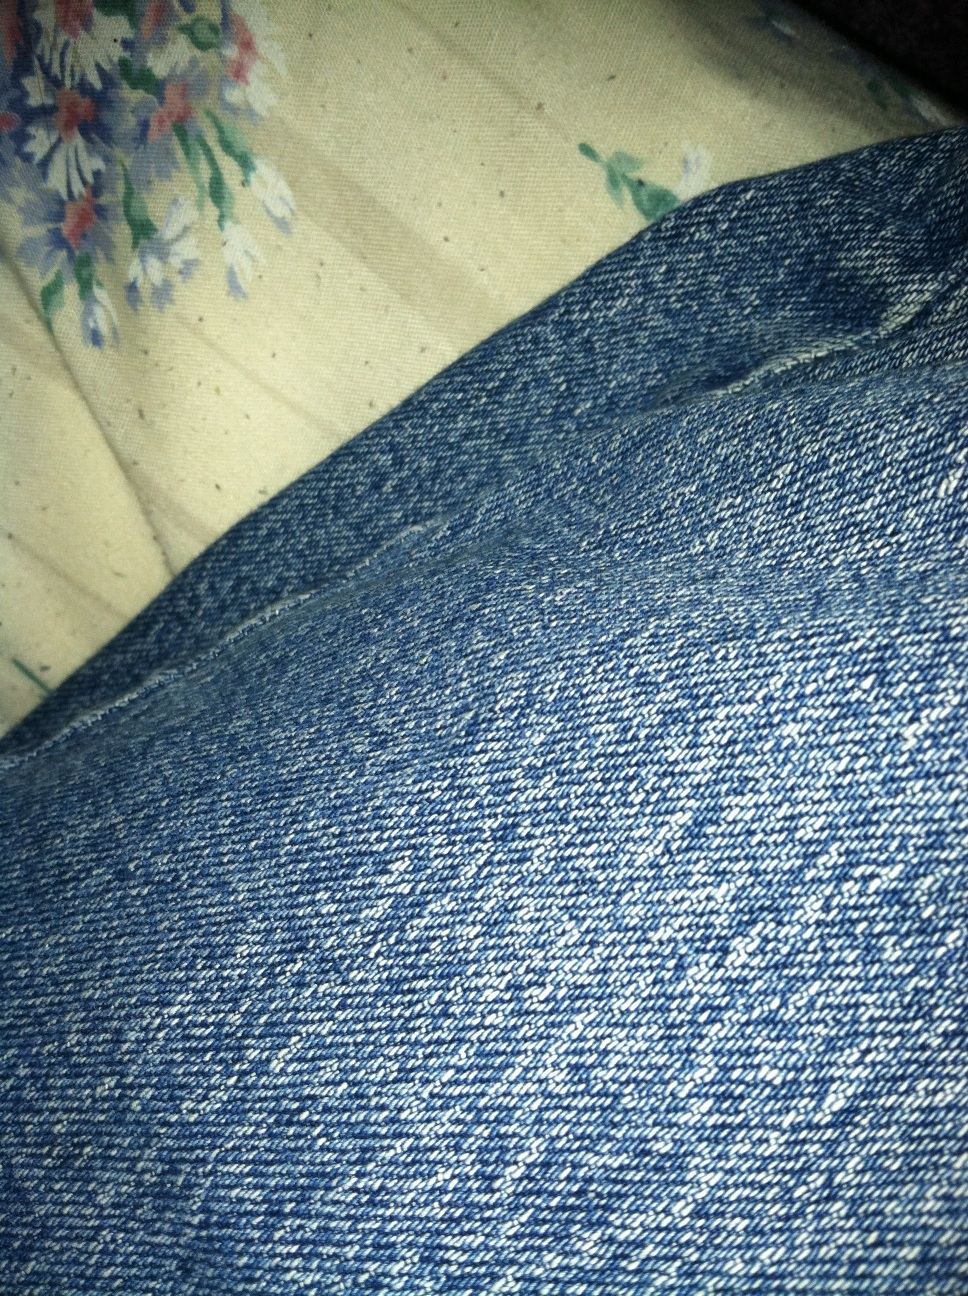Can you tell me a story about the journey of these jeans from creation to their current state? Certainly! Let’s take a creative journey with these jeans. It all began in a cotton field in Texas, where the cotton was harvested and transported to a textile factory. There, the cotton fibers were spun into yarn and dyed a rich blue. Skilled workers then wove the yarn into durable denim fabric, which was cut and sewn into these jeans at a bustling garment factory. The jeans were shipped to a retail store, where they caught the eye of their new owner. Over time, they became a staple in their wardrobe, accompanying them on many adventures and gradually conforming to their movements and lifestyle. Each tiny fray and fade tells a story of countless journeys, making these jeans more than just a piece of clothing but a chronicle of experiences. How might these jeans react if they were magically brought to life and could talk? If these jeans were magically brought to life, they might start by sharing tales of their creation and adventures. They’d talk about the bustling noise of the factory, the journey across oceans and lands to reach their owner, and the countless times they’ve been worn. They would have stories about each spill, each wash, and each time they were patched up. They might express pride in how they've held up and excitement over the many experiences they've been a part of. They would embody resilience and adaptability, recounting memories with a blend of nostalgia and excitement for future adventures. 